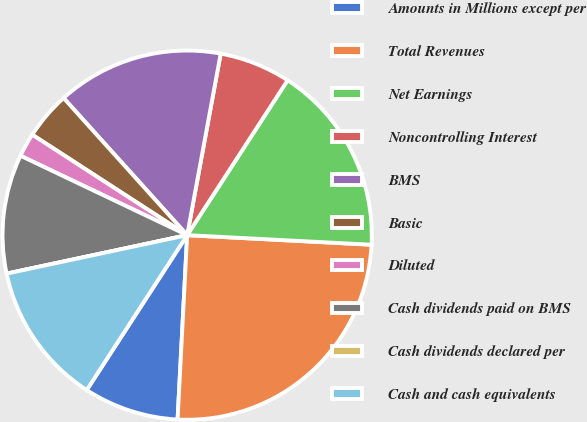Convert chart to OTSL. <chart><loc_0><loc_0><loc_500><loc_500><pie_chart><fcel>Amounts in Millions except per<fcel>Total Revenues<fcel>Net Earnings<fcel>Noncontrolling Interest<fcel>BMS<fcel>Basic<fcel>Diluted<fcel>Cash dividends paid on BMS<fcel>Cash dividends declared per<fcel>Cash and cash equivalents<nl><fcel>8.33%<fcel>25.0%<fcel>16.67%<fcel>6.25%<fcel>14.58%<fcel>4.17%<fcel>2.08%<fcel>10.42%<fcel>0.0%<fcel>12.5%<nl></chart> 